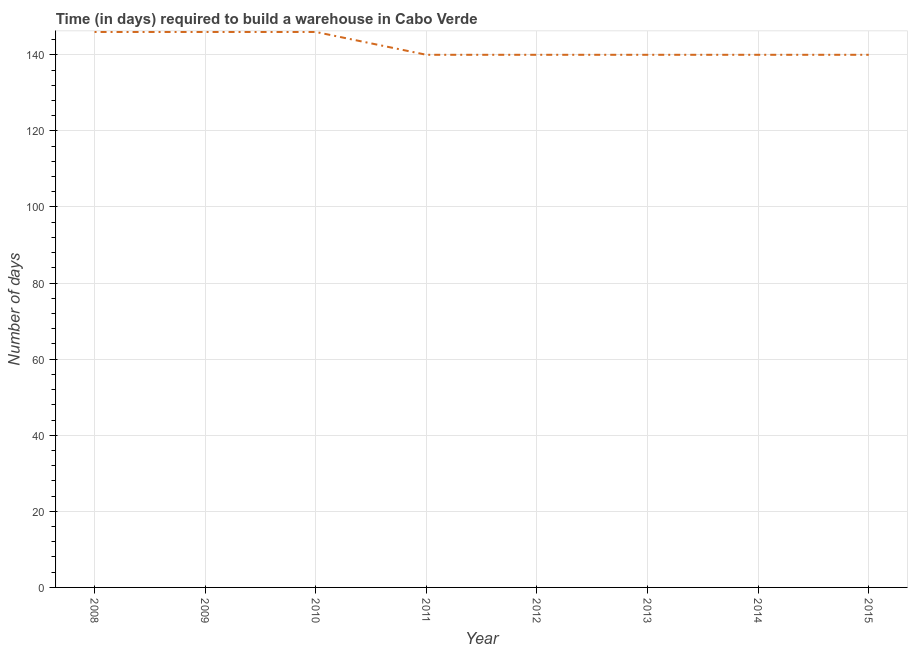What is the time required to build a warehouse in 2012?
Your response must be concise. 140. Across all years, what is the maximum time required to build a warehouse?
Make the answer very short. 146. Across all years, what is the minimum time required to build a warehouse?
Give a very brief answer. 140. What is the sum of the time required to build a warehouse?
Your answer should be very brief. 1138. What is the difference between the time required to build a warehouse in 2008 and 2012?
Your answer should be compact. 6. What is the average time required to build a warehouse per year?
Your answer should be very brief. 142.25. What is the median time required to build a warehouse?
Your response must be concise. 140. In how many years, is the time required to build a warehouse greater than 4 days?
Give a very brief answer. 8. Do a majority of the years between 2013 and 2010 (inclusive) have time required to build a warehouse greater than 8 days?
Make the answer very short. Yes. What is the ratio of the time required to build a warehouse in 2009 to that in 2015?
Provide a succinct answer. 1.04. Is the time required to build a warehouse in 2008 less than that in 2009?
Ensure brevity in your answer.  No. Is the difference between the time required to build a warehouse in 2008 and 2009 greater than the difference between any two years?
Offer a terse response. No. What is the difference between the highest and the second highest time required to build a warehouse?
Your response must be concise. 0. What is the difference between the highest and the lowest time required to build a warehouse?
Provide a short and direct response. 6. How many lines are there?
Give a very brief answer. 1. How many years are there in the graph?
Provide a short and direct response. 8. What is the difference between two consecutive major ticks on the Y-axis?
Make the answer very short. 20. Does the graph contain any zero values?
Give a very brief answer. No. Does the graph contain grids?
Your answer should be compact. Yes. What is the title of the graph?
Give a very brief answer. Time (in days) required to build a warehouse in Cabo Verde. What is the label or title of the X-axis?
Ensure brevity in your answer.  Year. What is the label or title of the Y-axis?
Provide a succinct answer. Number of days. What is the Number of days of 2008?
Offer a very short reply. 146. What is the Number of days of 2009?
Offer a very short reply. 146. What is the Number of days in 2010?
Keep it short and to the point. 146. What is the Number of days of 2011?
Keep it short and to the point. 140. What is the Number of days of 2012?
Make the answer very short. 140. What is the Number of days of 2013?
Your response must be concise. 140. What is the Number of days of 2014?
Keep it short and to the point. 140. What is the Number of days of 2015?
Your answer should be very brief. 140. What is the difference between the Number of days in 2008 and 2010?
Your answer should be very brief. 0. What is the difference between the Number of days in 2008 and 2014?
Ensure brevity in your answer.  6. What is the difference between the Number of days in 2009 and 2010?
Provide a short and direct response. 0. What is the difference between the Number of days in 2009 and 2012?
Give a very brief answer. 6. What is the difference between the Number of days in 2009 and 2013?
Keep it short and to the point. 6. What is the difference between the Number of days in 2009 and 2014?
Keep it short and to the point. 6. What is the difference between the Number of days in 2009 and 2015?
Your answer should be very brief. 6. What is the difference between the Number of days in 2010 and 2013?
Offer a terse response. 6. What is the difference between the Number of days in 2010 and 2014?
Provide a succinct answer. 6. What is the difference between the Number of days in 2011 and 2013?
Your answer should be compact. 0. What is the difference between the Number of days in 2012 and 2013?
Provide a succinct answer. 0. What is the difference between the Number of days in 2012 and 2014?
Keep it short and to the point. 0. What is the difference between the Number of days in 2013 and 2014?
Give a very brief answer. 0. What is the difference between the Number of days in 2014 and 2015?
Keep it short and to the point. 0. What is the ratio of the Number of days in 2008 to that in 2011?
Offer a terse response. 1.04. What is the ratio of the Number of days in 2008 to that in 2012?
Your response must be concise. 1.04. What is the ratio of the Number of days in 2008 to that in 2013?
Ensure brevity in your answer.  1.04. What is the ratio of the Number of days in 2008 to that in 2014?
Offer a very short reply. 1.04. What is the ratio of the Number of days in 2008 to that in 2015?
Your answer should be very brief. 1.04. What is the ratio of the Number of days in 2009 to that in 2010?
Provide a short and direct response. 1. What is the ratio of the Number of days in 2009 to that in 2011?
Give a very brief answer. 1.04. What is the ratio of the Number of days in 2009 to that in 2012?
Your response must be concise. 1.04. What is the ratio of the Number of days in 2009 to that in 2013?
Your answer should be very brief. 1.04. What is the ratio of the Number of days in 2009 to that in 2014?
Offer a terse response. 1.04. What is the ratio of the Number of days in 2009 to that in 2015?
Ensure brevity in your answer.  1.04. What is the ratio of the Number of days in 2010 to that in 2011?
Keep it short and to the point. 1.04. What is the ratio of the Number of days in 2010 to that in 2012?
Provide a short and direct response. 1.04. What is the ratio of the Number of days in 2010 to that in 2013?
Ensure brevity in your answer.  1.04. What is the ratio of the Number of days in 2010 to that in 2014?
Give a very brief answer. 1.04. What is the ratio of the Number of days in 2010 to that in 2015?
Your answer should be very brief. 1.04. What is the ratio of the Number of days in 2011 to that in 2015?
Your response must be concise. 1. What is the ratio of the Number of days in 2012 to that in 2015?
Provide a short and direct response. 1. What is the ratio of the Number of days in 2013 to that in 2014?
Ensure brevity in your answer.  1. What is the ratio of the Number of days in 2013 to that in 2015?
Provide a succinct answer. 1. 